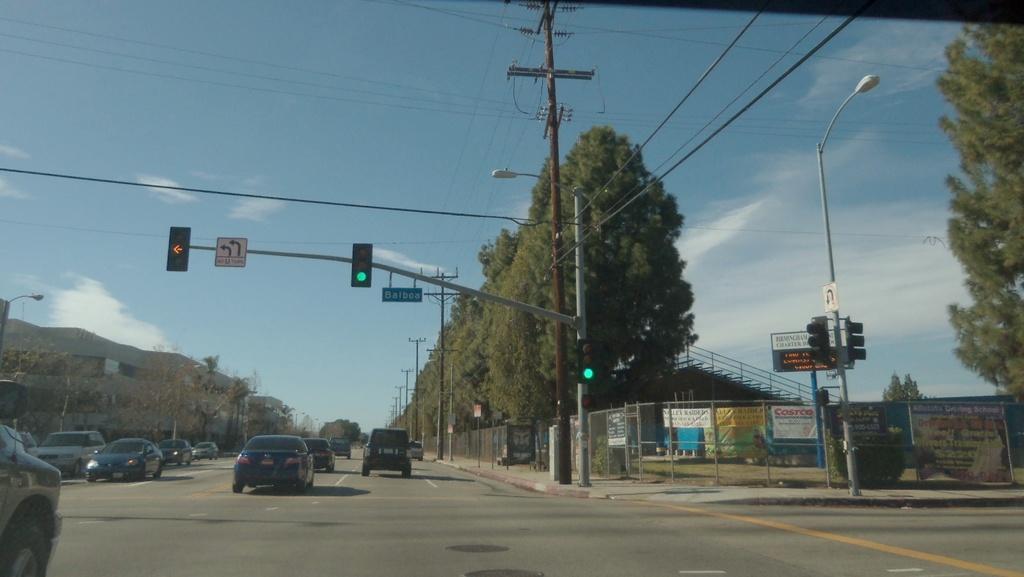What store is advertised on the white sign under the corner traffic light?
Keep it short and to the point. Costco. 